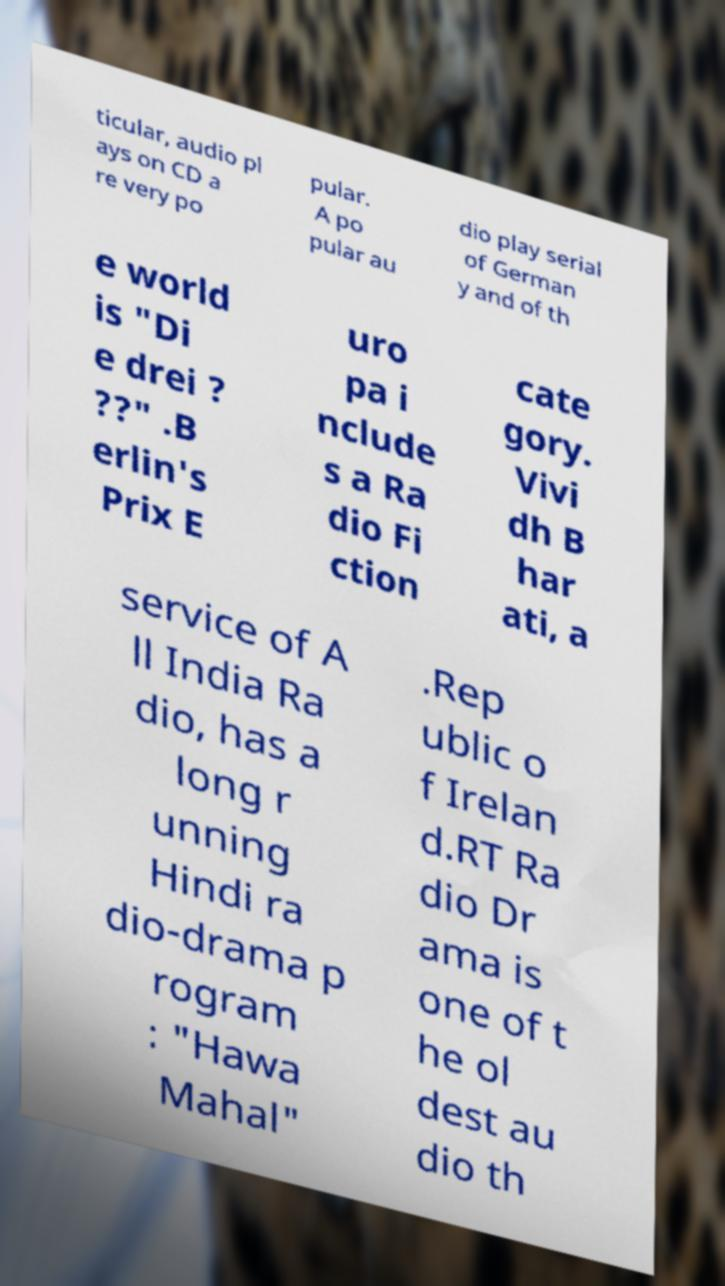Could you extract and type out the text from this image? ticular, audio pl ays on CD a re very po pular. A po pular au dio play serial of German y and of th e world is "Di e drei ? ??" .B erlin's Prix E uro pa i nclude s a Ra dio Fi ction cate gory. Vivi dh B har ati, a service of A ll India Ra dio, has a long r unning Hindi ra dio-drama p rogram : "Hawa Mahal" .Rep ublic o f Irelan d.RT Ra dio Dr ama is one of t he ol dest au dio th 